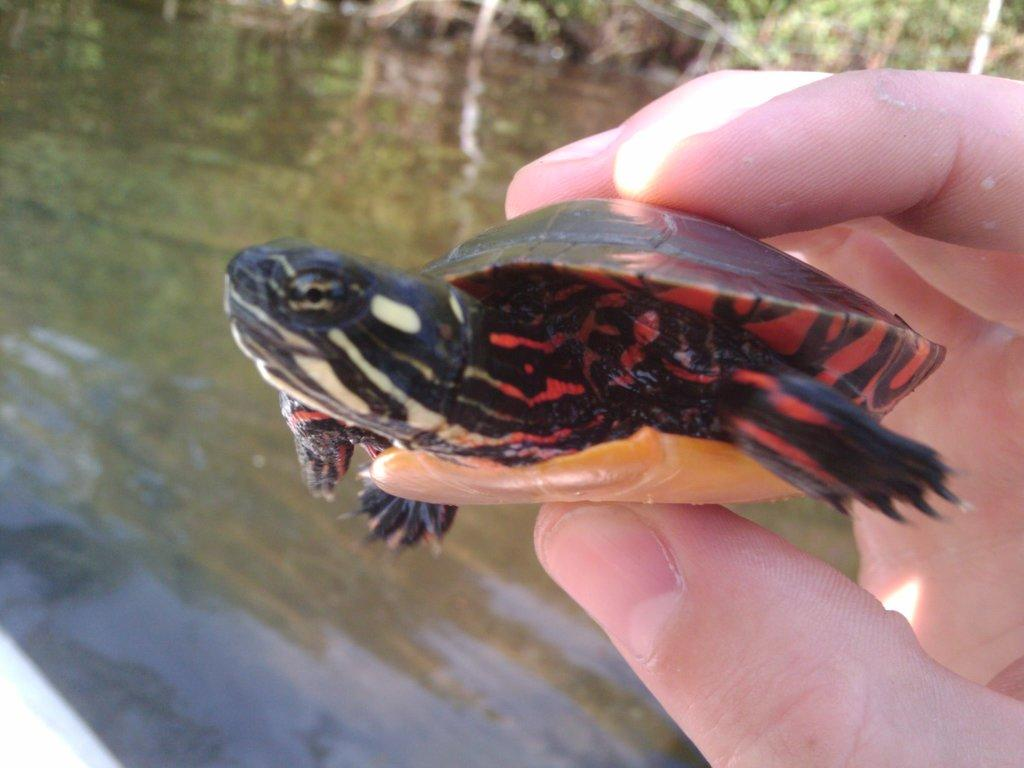What is the person in the image holding? The person is holding a turtle in the image. What can be seen in the background of the image? There is water and trees visible in the background of the image. Can you hear the bell ringing in the image? There is no bell present in the image, so it cannot be heard. 